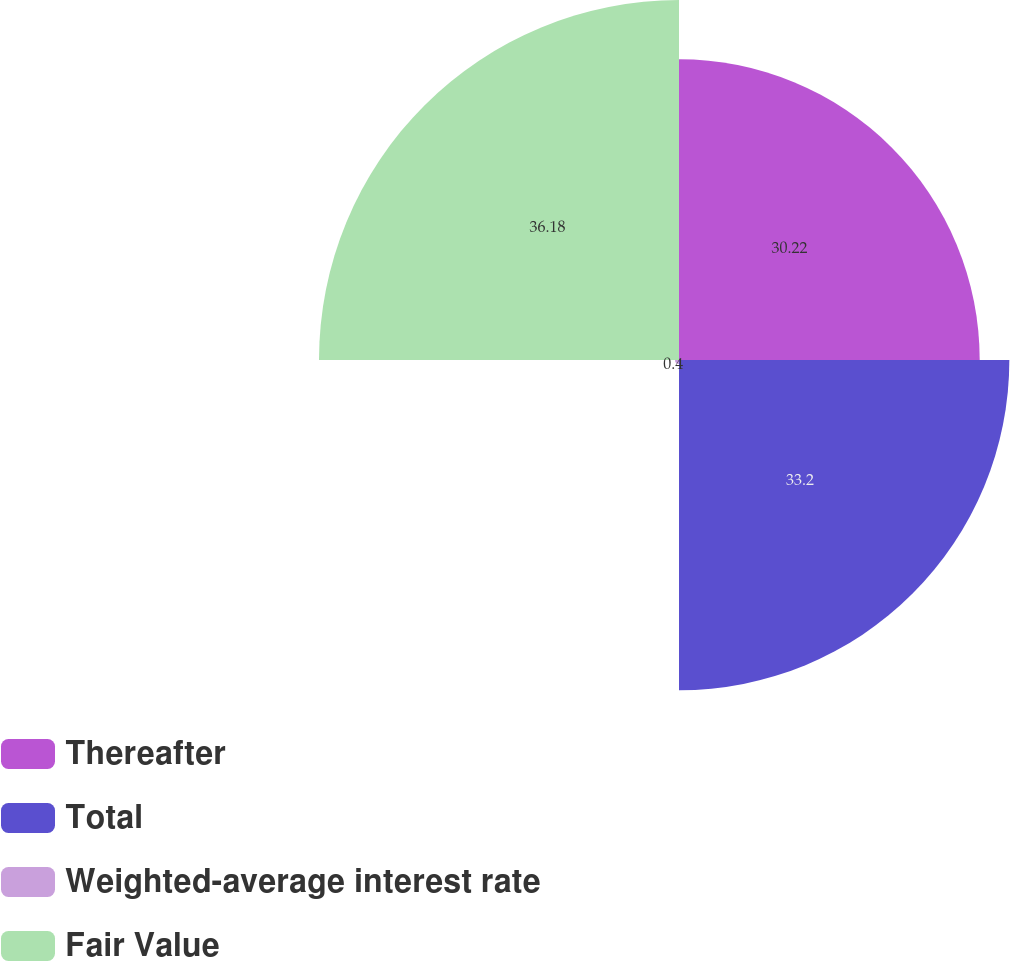<chart> <loc_0><loc_0><loc_500><loc_500><pie_chart><fcel>Thereafter<fcel>Total<fcel>Weighted-average interest rate<fcel>Fair Value<nl><fcel>30.22%<fcel>33.2%<fcel>0.4%<fcel>36.18%<nl></chart> 